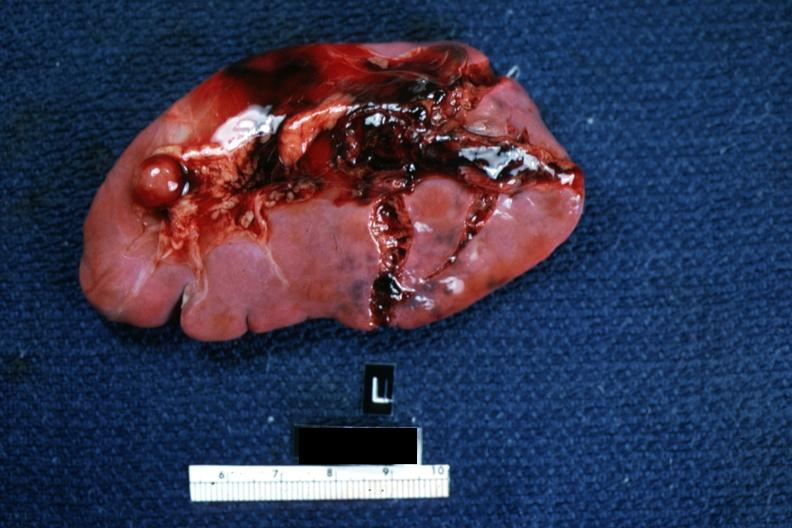s cysticercosis present?
Answer the question using a single word or phrase. No 